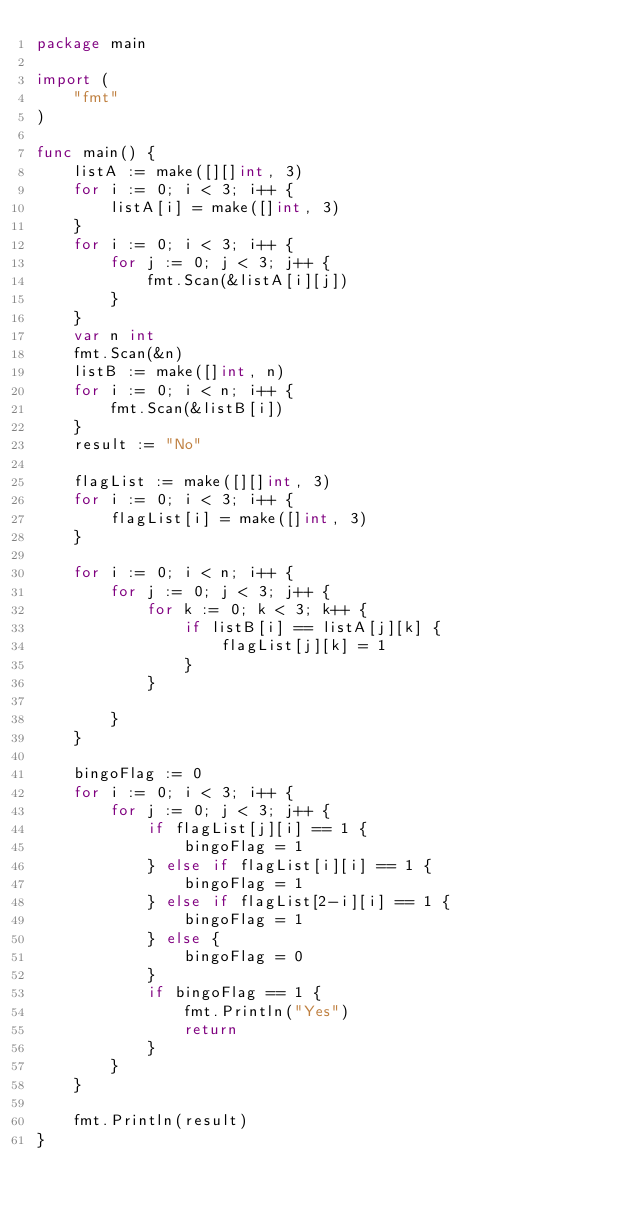Convert code to text. <code><loc_0><loc_0><loc_500><loc_500><_Go_>package main

import (
	"fmt"
)

func main() {
	listA := make([][]int, 3)
	for i := 0; i < 3; i++ {
		listA[i] = make([]int, 3)
	}
	for i := 0; i < 3; i++ {
		for j := 0; j < 3; j++ {
			fmt.Scan(&listA[i][j])
		}
	}
	var n int
	fmt.Scan(&n)
	listB := make([]int, n)
	for i := 0; i < n; i++ {
		fmt.Scan(&listB[i])
	}
	result := "No"

	flagList := make([][]int, 3)
	for i := 0; i < 3; i++ {
		flagList[i] = make([]int, 3)
	}

	for i := 0; i < n; i++ {
		for j := 0; j < 3; j++ {
			for k := 0; k < 3; k++ {
				if listB[i] == listA[j][k] {
					flagList[j][k] = 1
				}
			}

		}
	}

	bingoFlag := 0
	for i := 0; i < 3; i++ {
		for j := 0; j < 3; j++ {
			if flagList[j][i] == 1 {
				bingoFlag = 1
			} else if flagList[i][i] == 1 {
				bingoFlag = 1
			} else if flagList[2-i][i] == 1 {
				bingoFlag = 1
			} else {
				bingoFlag = 0
			}
			if bingoFlag == 1 {
				fmt.Println("Yes")
				return
			}
		}
	}

	fmt.Println(result)
}
</code> 